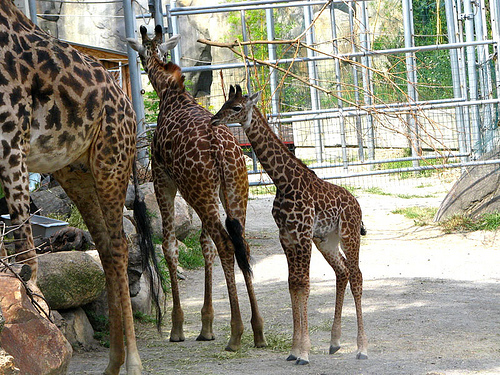How does the giraffe on the left interact with its surrounding? The giraffe on the left seems to be reaching out toward the structures above, possibly to browse on foliage or interact with the environment, showcasing the giraffe's natural inclination to extend its neck and explore high areas. 